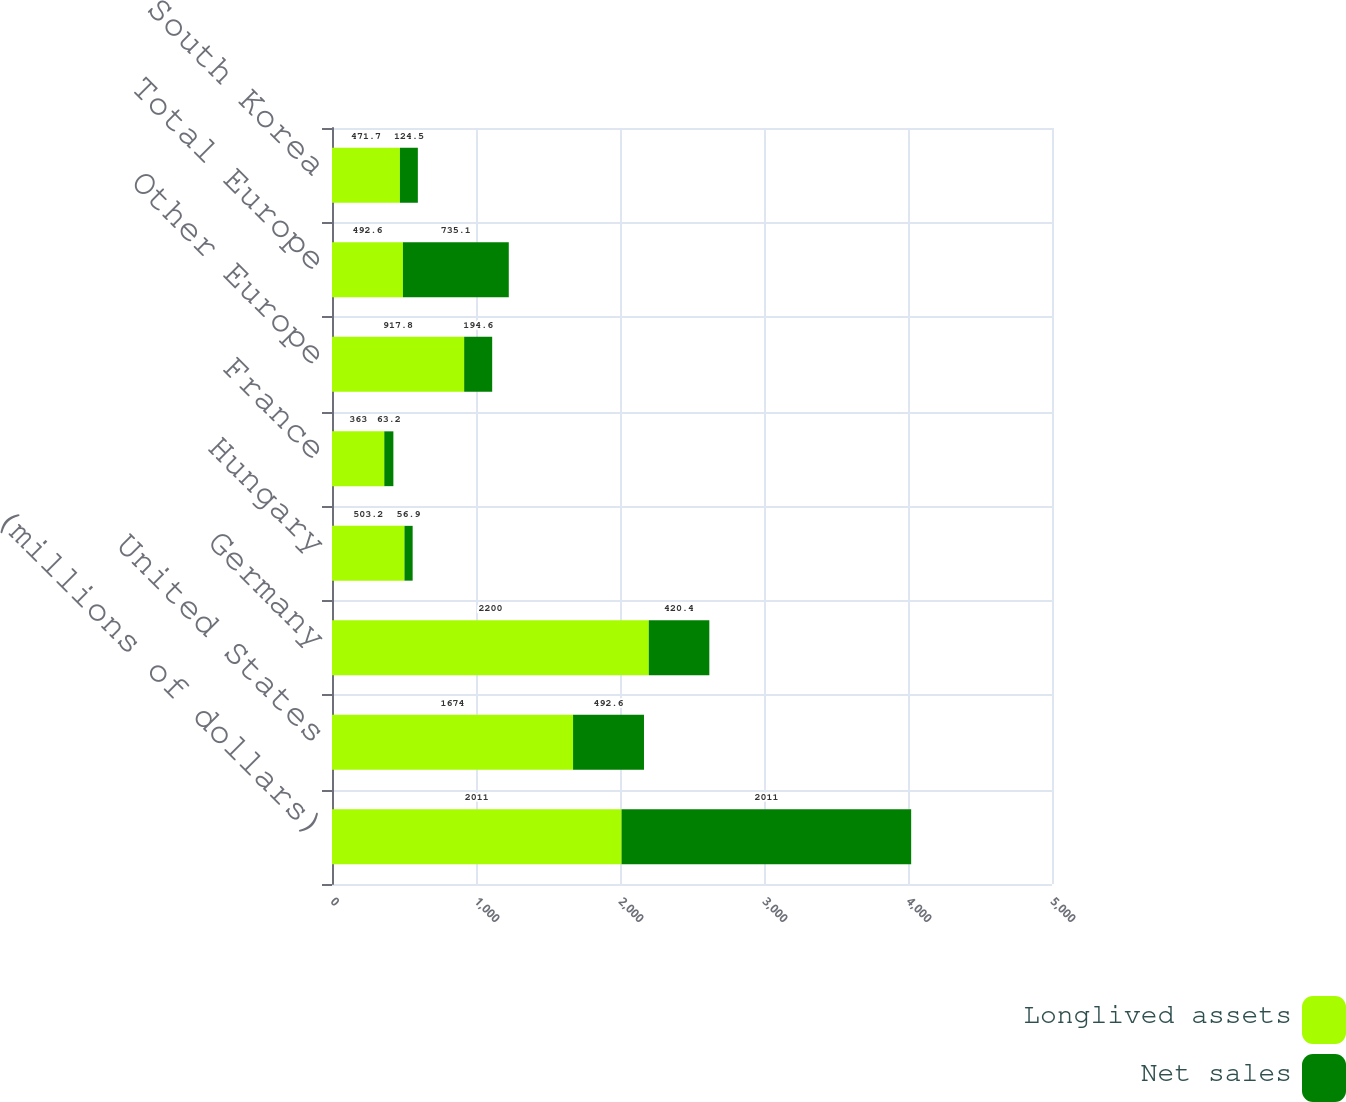Convert chart to OTSL. <chart><loc_0><loc_0><loc_500><loc_500><stacked_bar_chart><ecel><fcel>(millions of dollars)<fcel>United States<fcel>Germany<fcel>Hungary<fcel>France<fcel>Other Europe<fcel>Total Europe<fcel>South Korea<nl><fcel>Longlived assets<fcel>2011<fcel>1674<fcel>2200<fcel>503.2<fcel>363<fcel>917.8<fcel>492.6<fcel>471.7<nl><fcel>Net sales<fcel>2011<fcel>492.6<fcel>420.4<fcel>56.9<fcel>63.2<fcel>194.6<fcel>735.1<fcel>124.5<nl></chart> 